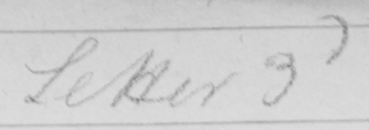Please transcribe the handwritten text in this image. Letter 3d 